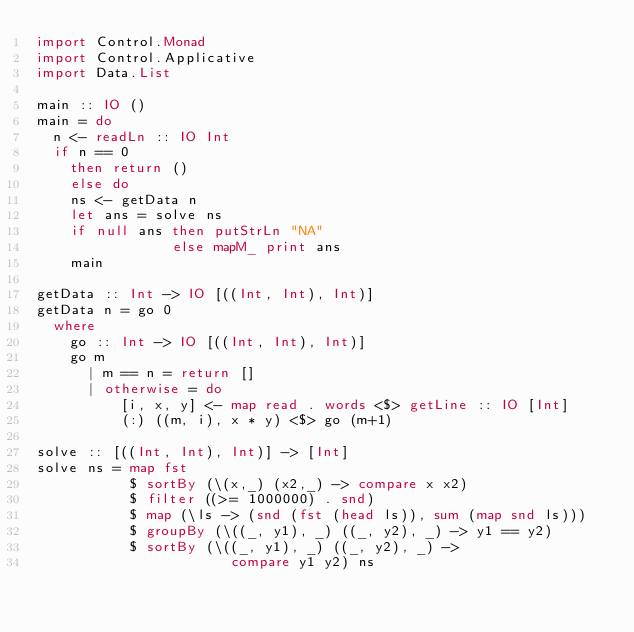Convert code to text. <code><loc_0><loc_0><loc_500><loc_500><_Haskell_>import Control.Monad
import Control.Applicative
import Data.List
  
main :: IO ()
main = do
  n <- readLn :: IO Int
  if n == 0
    then return ()
    else do
    ns <- getData n
    let ans = solve ns
    if null ans then putStrLn "NA"
                else mapM_ print ans
    main
  
getData :: Int -> IO [((Int, Int), Int)]
getData n = go 0
  where
    go :: Int -> IO [((Int, Int), Int)]
    go m
      | m == n = return []
      | otherwise = do
          [i, x, y] <- map read . words <$> getLine :: IO [Int]
          (:) ((m, i), x * y) <$> go (m+1)

solve :: [((Int, Int), Int)] -> [Int]
solve ns = map fst
           $ sortBy (\(x,_) (x2,_) -> compare x x2)
           $ filter ((>= 1000000) . snd)
           $ map (\ls -> (snd (fst (head ls)), sum (map snd ls)))
           $ groupBy (\((_, y1), _) ((_, y2), _) -> y1 == y2)
           $ sortBy (\((_, y1), _) ((_, y2), _) ->
                       compare y1 y2) ns</code> 